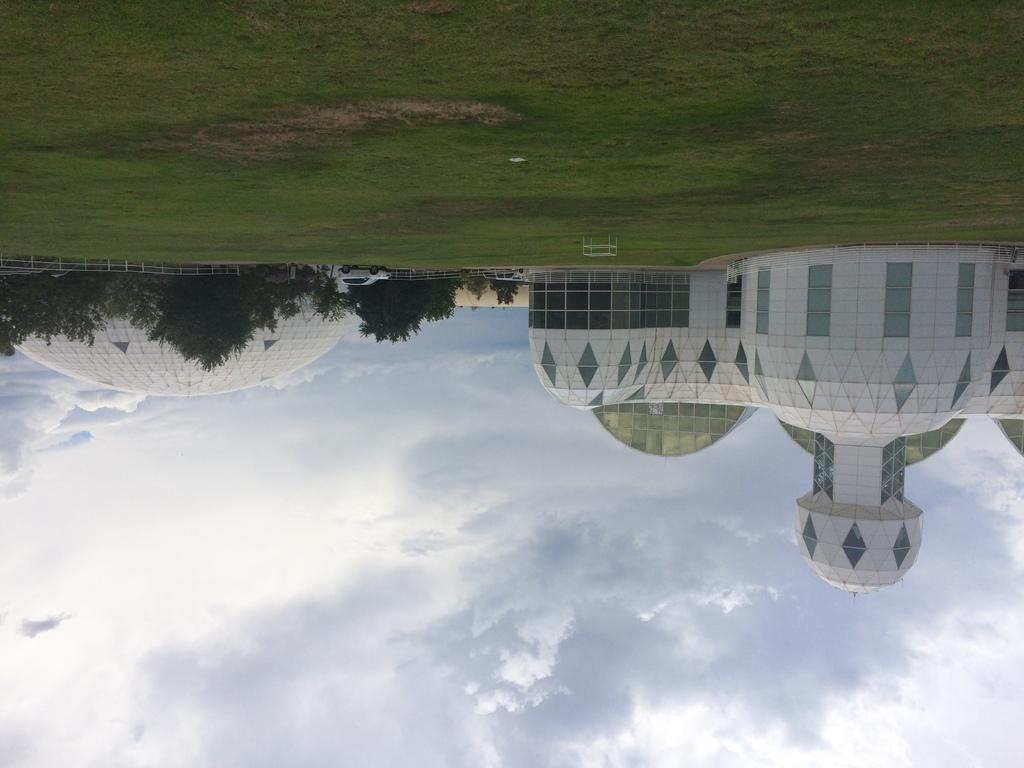What type of vegetation is present in the image? There is grass in the image. What else can be seen in the image besides grass? There are trees and buildings in the image. What is visible in the background of the image? The sky is visible in the image, and there are clouds present. What type of art is the minister creating in the image? There is no minister or art present in the image. What is the limit of the grass in the image? The image does not specify a limit for the grass; it simply shows the grass in its natural state. 